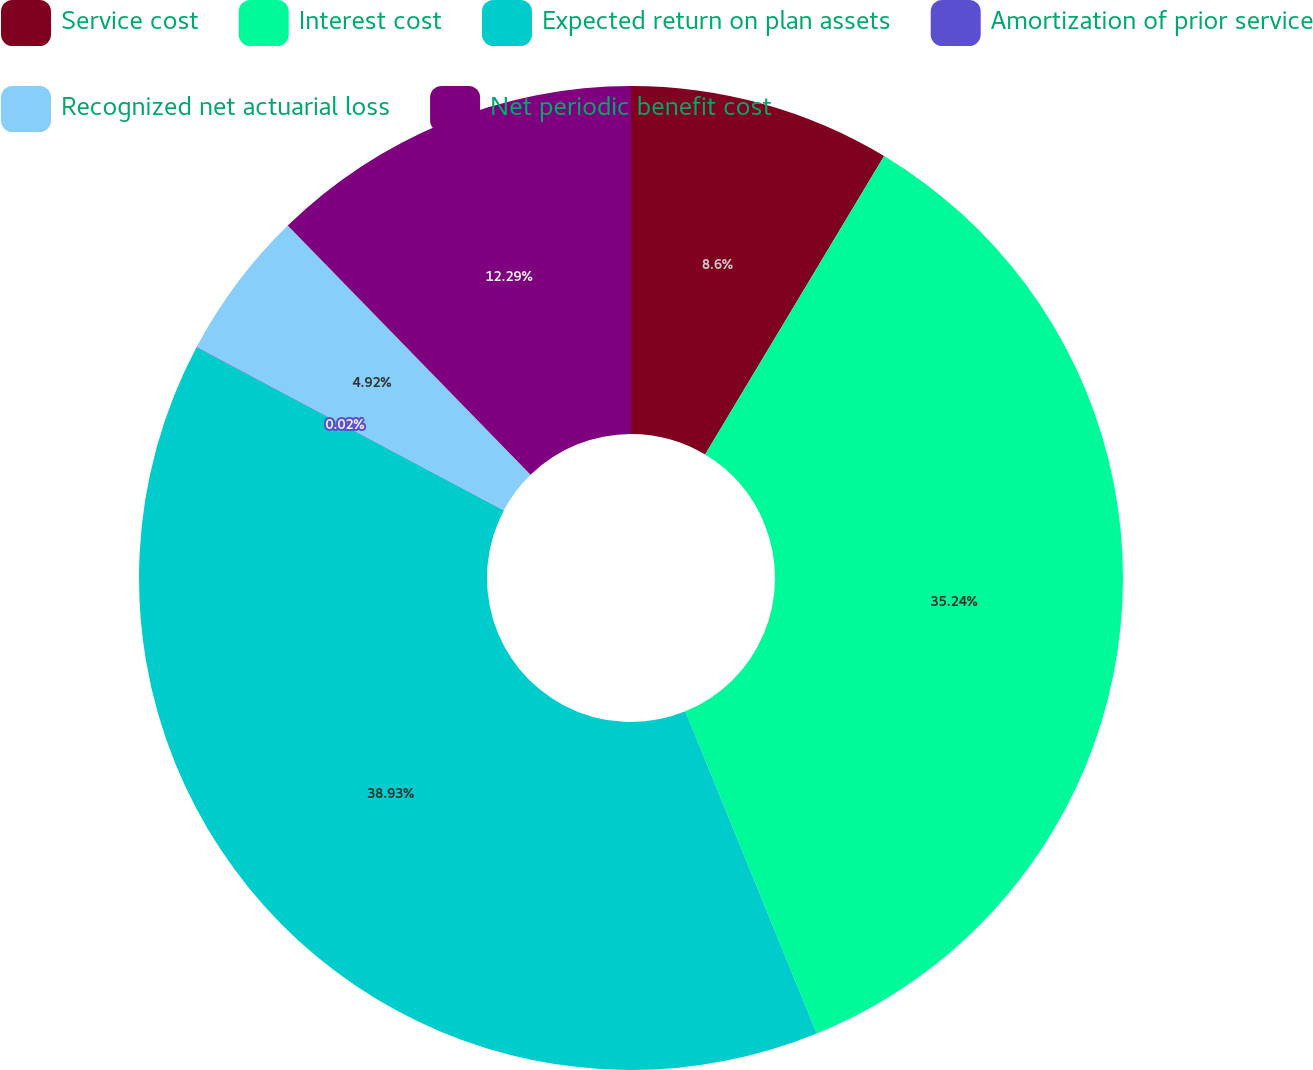Convert chart. <chart><loc_0><loc_0><loc_500><loc_500><pie_chart><fcel>Service cost<fcel>Interest cost<fcel>Expected return on plan assets<fcel>Amortization of prior service<fcel>Recognized net actuarial loss<fcel>Net periodic benefit cost<nl><fcel>8.6%<fcel>35.24%<fcel>38.93%<fcel>0.02%<fcel>4.92%<fcel>12.29%<nl></chart> 